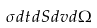<formula> <loc_0><loc_0><loc_500><loc_500>\sigma d t d S d v d \Omega</formula> 